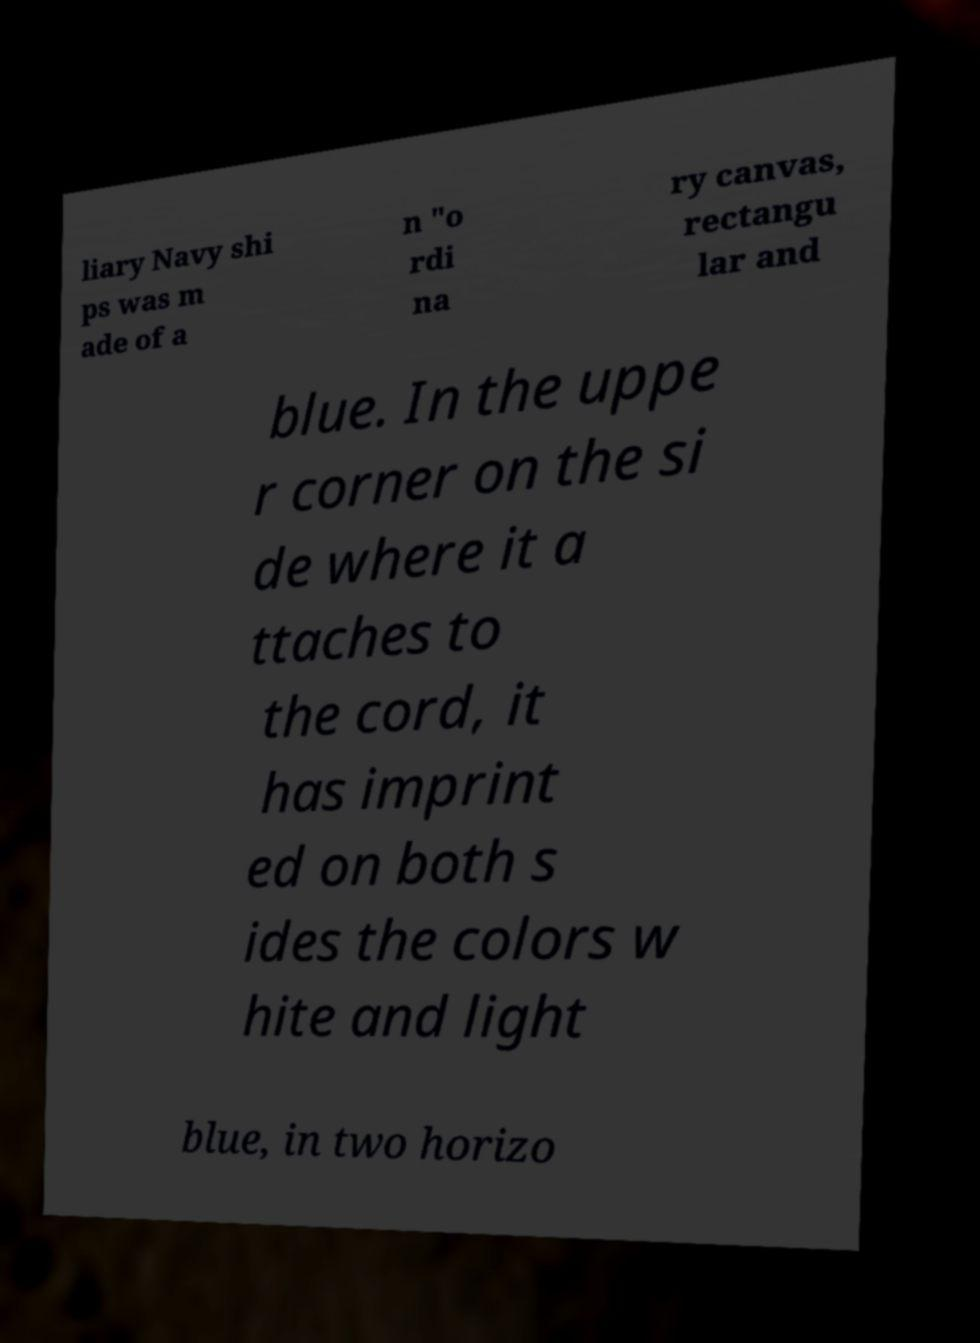Could you assist in decoding the text presented in this image and type it out clearly? liary Navy shi ps was m ade of a n "o rdi na ry canvas, rectangu lar and blue. In the uppe r corner on the si de where it a ttaches to the cord, it has imprint ed on both s ides the colors w hite and light blue, in two horizo 